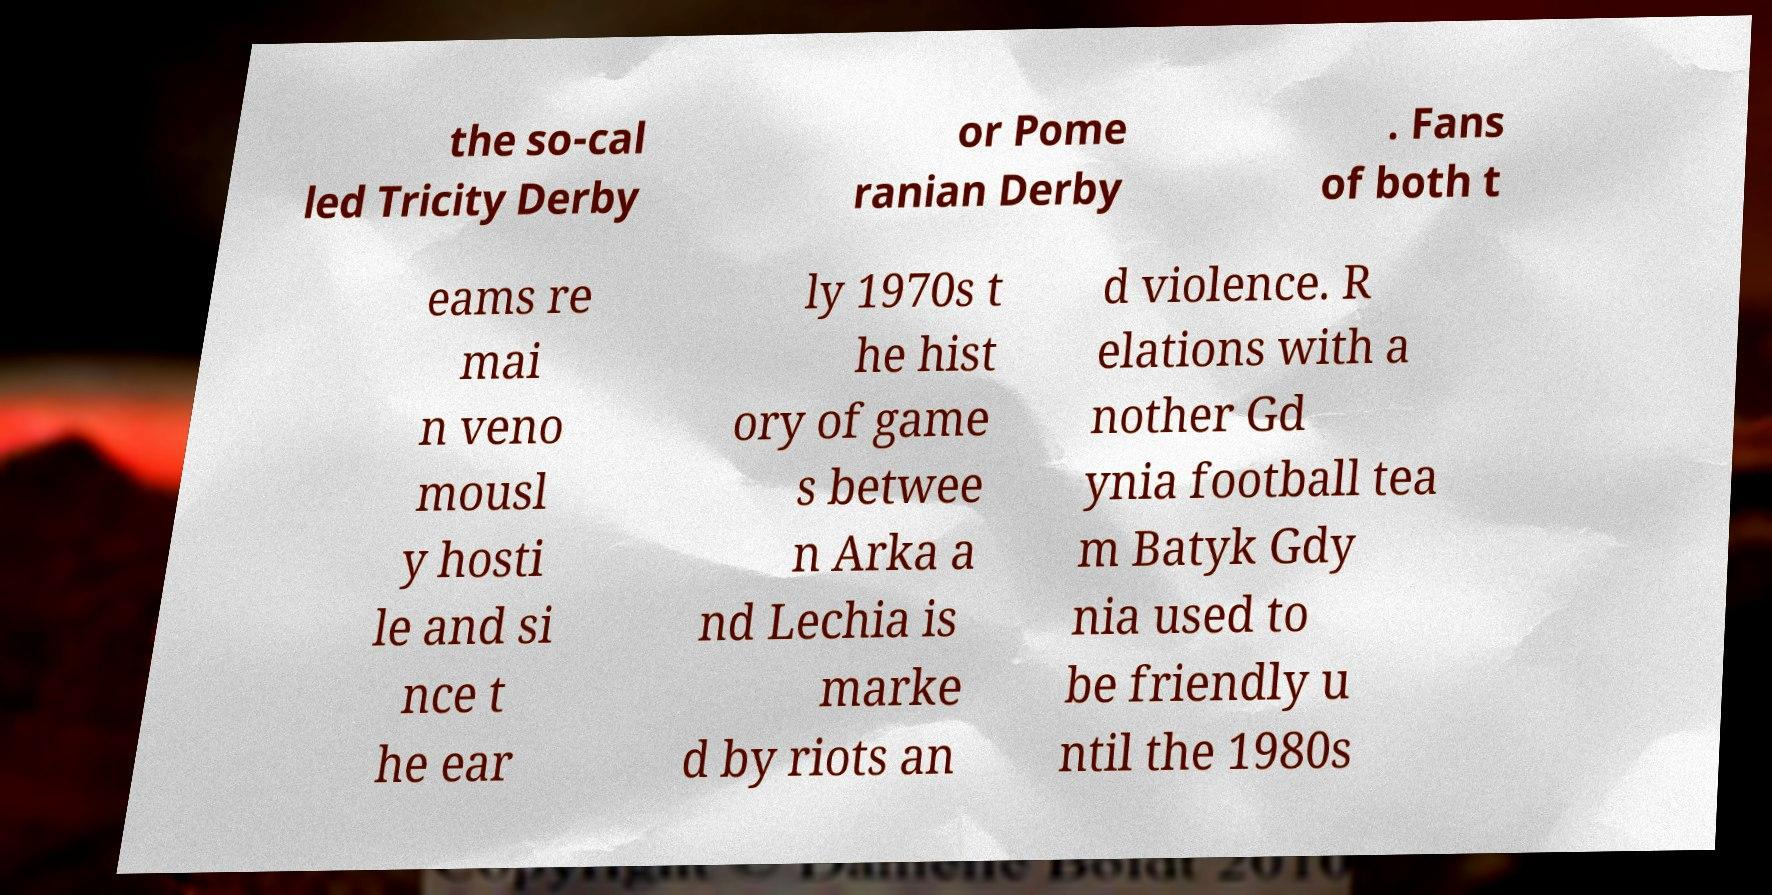Can you accurately transcribe the text from the provided image for me? the so-cal led Tricity Derby or Pome ranian Derby . Fans of both t eams re mai n veno mousl y hosti le and si nce t he ear ly 1970s t he hist ory of game s betwee n Arka a nd Lechia is marke d by riots an d violence. R elations with a nother Gd ynia football tea m Batyk Gdy nia used to be friendly u ntil the 1980s 